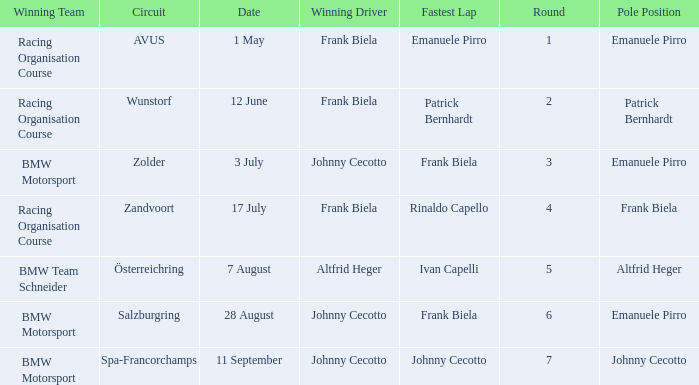Could you help me parse every detail presented in this table? {'header': ['Winning Team', 'Circuit', 'Date', 'Winning Driver', 'Fastest Lap', 'Round', 'Pole Position'], 'rows': [['Racing Organisation Course', 'AVUS', '1 May', 'Frank Biela', 'Emanuele Pirro', '1', 'Emanuele Pirro'], ['Racing Organisation Course', 'Wunstorf', '12 June', 'Frank Biela', 'Patrick Bernhardt', '2', 'Patrick Bernhardt'], ['BMW Motorsport', 'Zolder', '3 July', 'Johnny Cecotto', 'Frank Biela', '3', 'Emanuele Pirro'], ['Racing Organisation Course', 'Zandvoort', '17 July', 'Frank Biela', 'Rinaldo Capello', '4', 'Frank Biela'], ['BMW Team Schneider', 'Österreichring', '7 August', 'Altfrid Heger', 'Ivan Capelli', '5', 'Altfrid Heger'], ['BMW Motorsport', 'Salzburgring', '28 August', 'Johnny Cecotto', 'Frank Biela', '6', 'Emanuele Pirro'], ['BMW Motorsport', 'Spa-Francorchamps', '11 September', 'Johnny Cecotto', 'Johnny Cecotto', '7', 'Johnny Cecotto']]} Who was the winning team on the circuit Zolder? BMW Motorsport. 